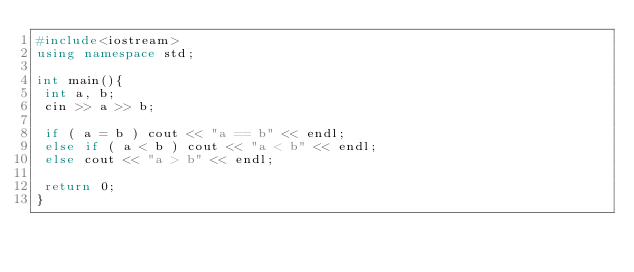<code> <loc_0><loc_0><loc_500><loc_500><_C++_>#include<iostream>
using namespace std;

int main(){
 int a, b;
 cin >> a >> b;

 if ( a = b ) cout << "a == b" << endl;
 else if ( a < b ) cout << "a < b" << endl;
 else cout << "a > b" << endl;

 return 0;
}</code> 